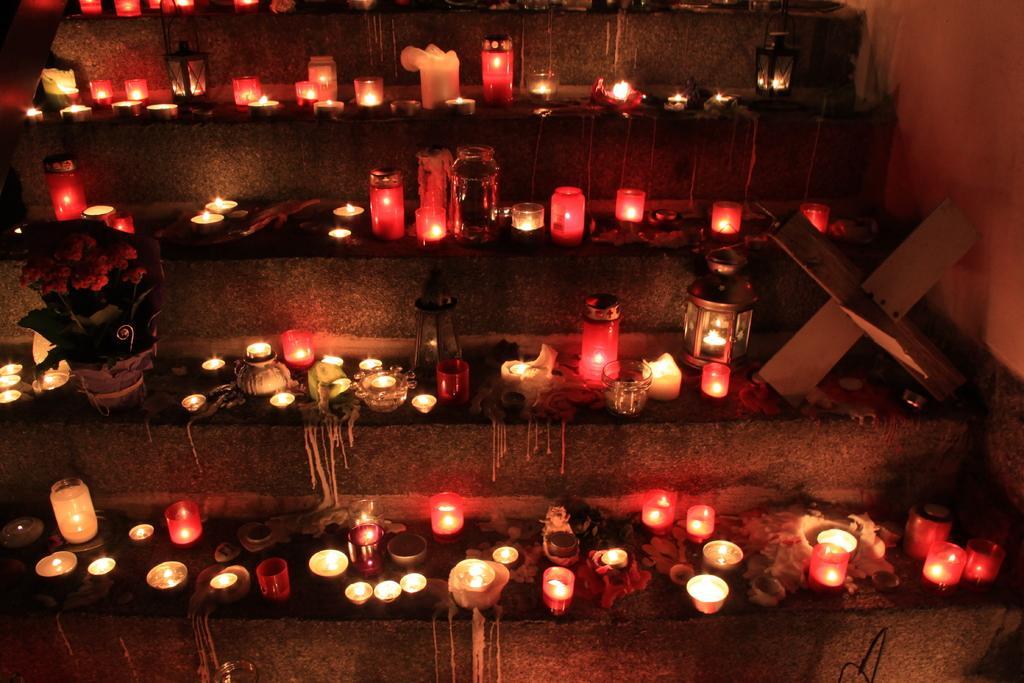Describe this image in one or two sentences. In the image we can see some steps, on the steps we can see some candles, lights and plants. In the top right corner of the image we can see the wall. 